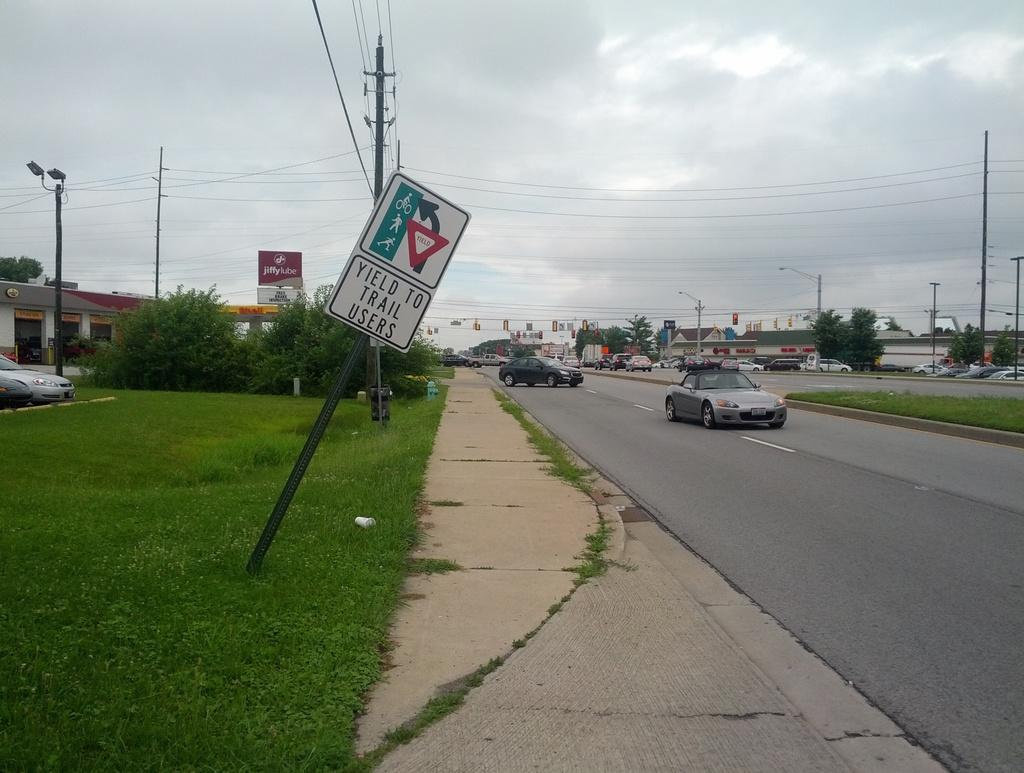<image>
Render a clear and concise summary of the photo. A lopsided sign which reads Yield to trail users. 